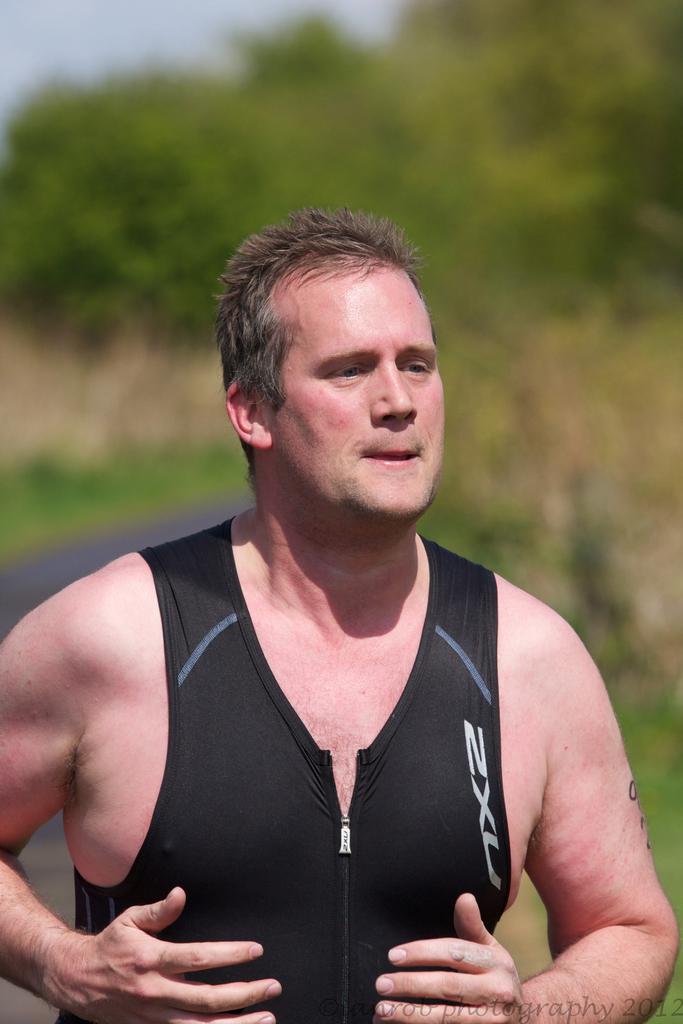What are the letters on his shirt?
Provide a short and direct response. Nxc. 